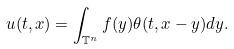<formula> <loc_0><loc_0><loc_500><loc_500>u ( t , x ) = \int _ { { \mathbb { T } } ^ { n } } f ( y ) \theta ( t , x - y ) d y .</formula> 